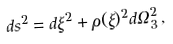Convert formula to latex. <formula><loc_0><loc_0><loc_500><loc_500>d s ^ { 2 } = d \xi ^ { 2 } + \rho ( \xi ) ^ { 2 } d \Omega _ { 3 } ^ { 2 } \, ,</formula> 